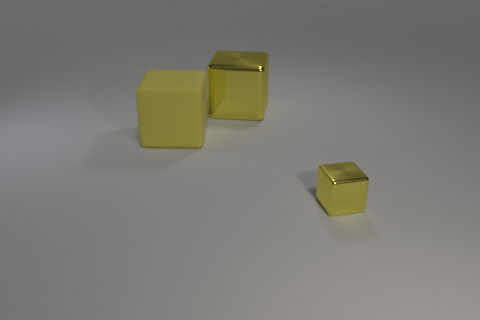How many yellow cubes are in the image? There are three yellow cubes present in the image. 